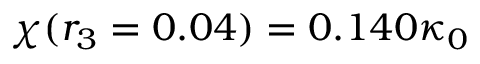<formula> <loc_0><loc_0><loc_500><loc_500>\chi ( r _ { 3 } = 0 . 0 4 ) = 0 . 1 4 0 \kappa _ { 0 }</formula> 